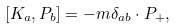Convert formula to latex. <formula><loc_0><loc_0><loc_500><loc_500>[ K _ { a } , P _ { b } ] = - m \delta _ { a b } \cdot P _ { + } ,</formula> 